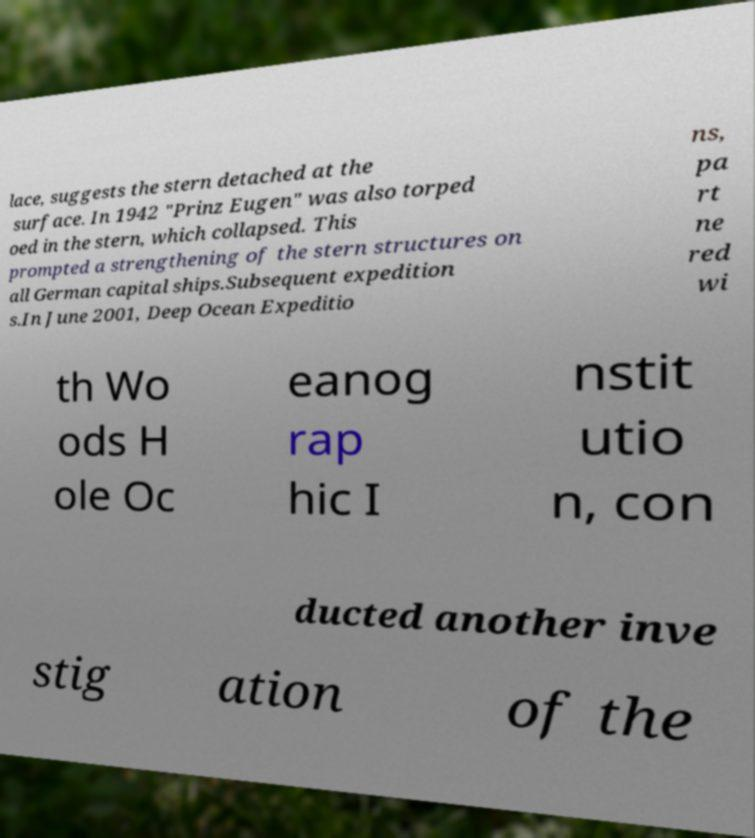Please identify and transcribe the text found in this image. lace, suggests the stern detached at the surface. In 1942 "Prinz Eugen" was also torped oed in the stern, which collapsed. This prompted a strengthening of the stern structures on all German capital ships.Subsequent expedition s.In June 2001, Deep Ocean Expeditio ns, pa rt ne red wi th Wo ods H ole Oc eanog rap hic I nstit utio n, con ducted another inve stig ation of the 